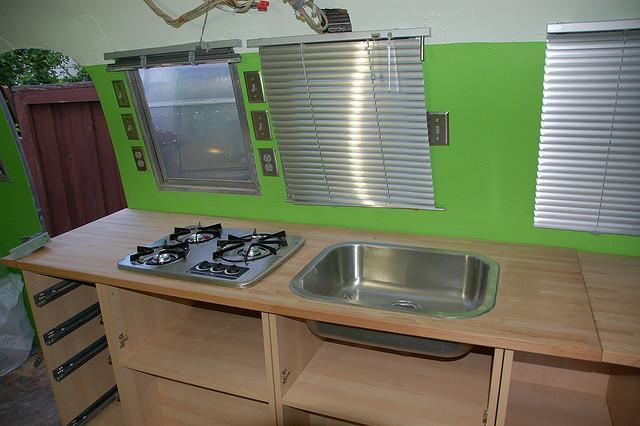How many ovens can be seen?
Give a very brief answer. 2. How many sinks are there?
Give a very brief answer. 1. 